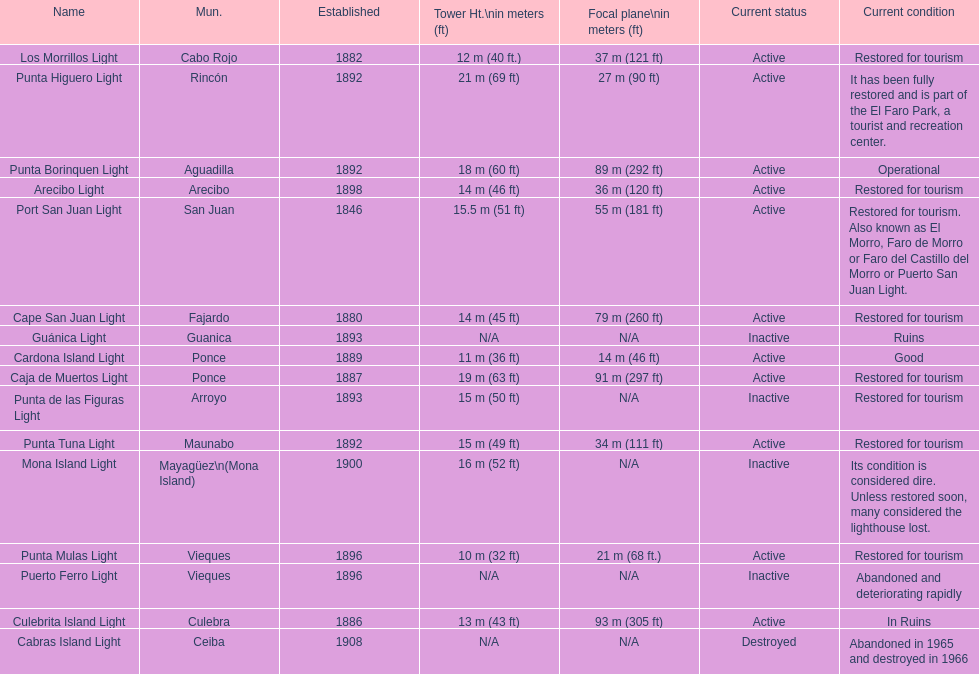What is the largest tower Punta Higuero Light. 